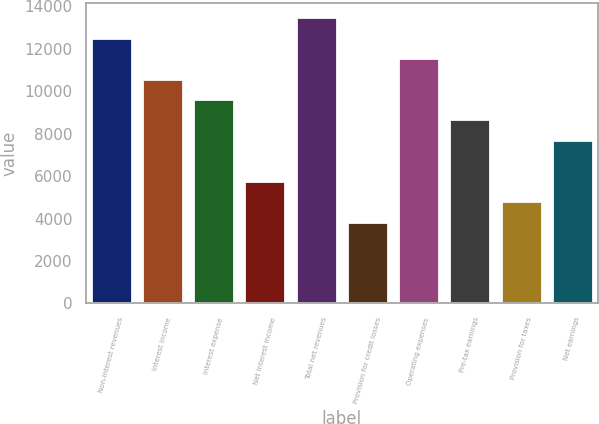<chart> <loc_0><loc_0><loc_500><loc_500><bar_chart><fcel>Non-interest revenues<fcel>Interest income<fcel>Interest expense<fcel>Net interest income<fcel>Total net revenues<fcel>Provision for credit losses<fcel>Operating expenses<fcel>Pre-tax earnings<fcel>Provision for taxes<fcel>Net earnings<nl><fcel>12526.6<fcel>10599.5<fcel>9636<fcel>5781.92<fcel>13490.1<fcel>3854.88<fcel>11563<fcel>8672.48<fcel>4818.4<fcel>7708.96<nl></chart> 